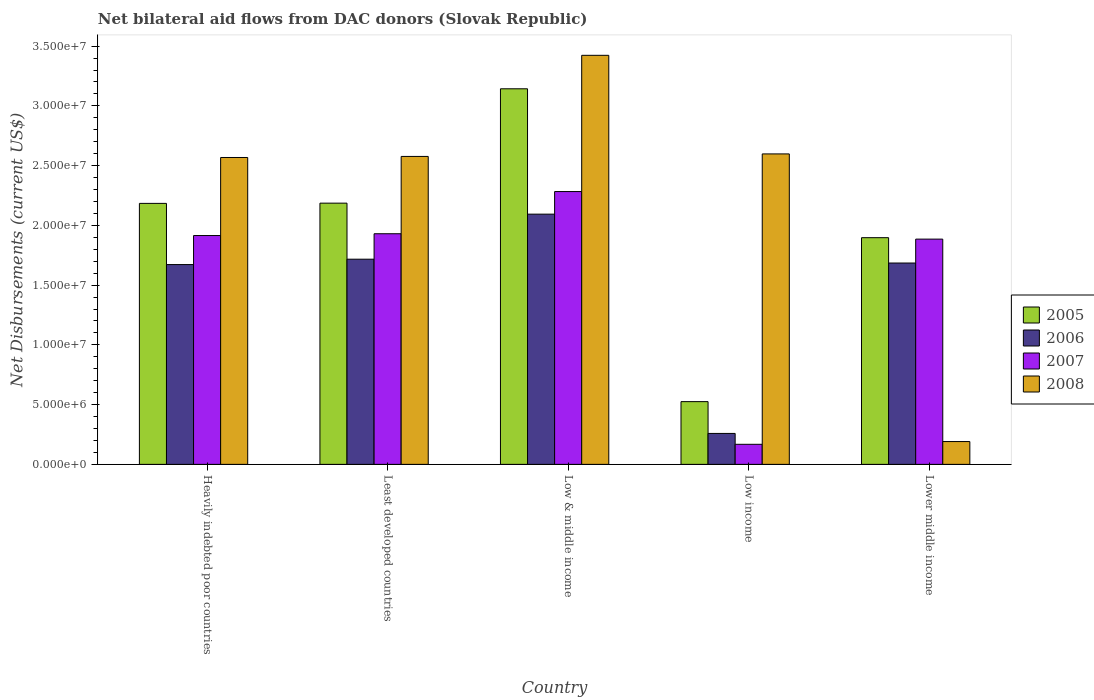How many different coloured bars are there?
Your answer should be compact. 4. Are the number of bars on each tick of the X-axis equal?
Offer a very short reply. Yes. What is the label of the 1st group of bars from the left?
Ensure brevity in your answer.  Heavily indebted poor countries. What is the net bilateral aid flows in 2005 in Low & middle income?
Your response must be concise. 3.14e+07. Across all countries, what is the maximum net bilateral aid flows in 2005?
Keep it short and to the point. 3.14e+07. Across all countries, what is the minimum net bilateral aid flows in 2006?
Make the answer very short. 2.59e+06. What is the total net bilateral aid flows in 2006 in the graph?
Provide a succinct answer. 7.43e+07. What is the difference between the net bilateral aid flows in 2007 in Heavily indebted poor countries and that in Low income?
Provide a short and direct response. 1.75e+07. What is the difference between the net bilateral aid flows in 2006 in Low income and the net bilateral aid flows in 2005 in Low & middle income?
Provide a succinct answer. -2.88e+07. What is the average net bilateral aid flows in 2006 per country?
Offer a terse response. 1.49e+07. What is the difference between the net bilateral aid flows of/in 2008 and net bilateral aid flows of/in 2005 in Lower middle income?
Offer a very short reply. -1.71e+07. In how many countries, is the net bilateral aid flows in 2005 greater than 29000000 US$?
Your response must be concise. 1. What is the ratio of the net bilateral aid flows in 2005 in Heavily indebted poor countries to that in Low & middle income?
Your answer should be compact. 0.69. Is the net bilateral aid flows in 2005 in Heavily indebted poor countries less than that in Lower middle income?
Offer a very short reply. No. Is the difference between the net bilateral aid flows in 2008 in Heavily indebted poor countries and Least developed countries greater than the difference between the net bilateral aid flows in 2005 in Heavily indebted poor countries and Least developed countries?
Give a very brief answer. No. What is the difference between the highest and the second highest net bilateral aid flows in 2006?
Give a very brief answer. 3.77e+06. What is the difference between the highest and the lowest net bilateral aid flows in 2007?
Make the answer very short. 2.12e+07. In how many countries, is the net bilateral aid flows in 2007 greater than the average net bilateral aid flows in 2007 taken over all countries?
Offer a very short reply. 4. Is it the case that in every country, the sum of the net bilateral aid flows in 2007 and net bilateral aid flows in 2006 is greater than the sum of net bilateral aid flows in 2008 and net bilateral aid flows in 2005?
Provide a succinct answer. No. How many bars are there?
Provide a succinct answer. 20. Are all the bars in the graph horizontal?
Make the answer very short. No. How many countries are there in the graph?
Ensure brevity in your answer.  5. What is the difference between two consecutive major ticks on the Y-axis?
Your answer should be very brief. 5.00e+06. Does the graph contain any zero values?
Give a very brief answer. No. Does the graph contain grids?
Provide a short and direct response. No. How many legend labels are there?
Ensure brevity in your answer.  4. How are the legend labels stacked?
Your response must be concise. Vertical. What is the title of the graph?
Your answer should be very brief. Net bilateral aid flows from DAC donors (Slovak Republic). Does "1979" appear as one of the legend labels in the graph?
Your answer should be very brief. No. What is the label or title of the Y-axis?
Offer a terse response. Net Disbursements (current US$). What is the Net Disbursements (current US$) in 2005 in Heavily indebted poor countries?
Give a very brief answer. 2.18e+07. What is the Net Disbursements (current US$) in 2006 in Heavily indebted poor countries?
Make the answer very short. 1.67e+07. What is the Net Disbursements (current US$) of 2007 in Heavily indebted poor countries?
Give a very brief answer. 1.92e+07. What is the Net Disbursements (current US$) of 2008 in Heavily indebted poor countries?
Make the answer very short. 2.57e+07. What is the Net Disbursements (current US$) in 2005 in Least developed countries?
Your response must be concise. 2.19e+07. What is the Net Disbursements (current US$) in 2006 in Least developed countries?
Your answer should be very brief. 1.72e+07. What is the Net Disbursements (current US$) in 2007 in Least developed countries?
Your answer should be very brief. 1.93e+07. What is the Net Disbursements (current US$) in 2008 in Least developed countries?
Ensure brevity in your answer.  2.58e+07. What is the Net Disbursements (current US$) of 2005 in Low & middle income?
Make the answer very short. 3.14e+07. What is the Net Disbursements (current US$) of 2006 in Low & middle income?
Your answer should be very brief. 2.09e+07. What is the Net Disbursements (current US$) in 2007 in Low & middle income?
Offer a very short reply. 2.28e+07. What is the Net Disbursements (current US$) in 2008 in Low & middle income?
Provide a short and direct response. 3.42e+07. What is the Net Disbursements (current US$) in 2005 in Low income?
Make the answer very short. 5.25e+06. What is the Net Disbursements (current US$) in 2006 in Low income?
Provide a succinct answer. 2.59e+06. What is the Net Disbursements (current US$) of 2007 in Low income?
Offer a terse response. 1.68e+06. What is the Net Disbursements (current US$) in 2008 in Low income?
Offer a terse response. 2.60e+07. What is the Net Disbursements (current US$) of 2005 in Lower middle income?
Ensure brevity in your answer.  1.90e+07. What is the Net Disbursements (current US$) in 2006 in Lower middle income?
Ensure brevity in your answer.  1.68e+07. What is the Net Disbursements (current US$) of 2007 in Lower middle income?
Your answer should be very brief. 1.88e+07. What is the Net Disbursements (current US$) in 2008 in Lower middle income?
Ensure brevity in your answer.  1.91e+06. Across all countries, what is the maximum Net Disbursements (current US$) of 2005?
Your answer should be very brief. 3.14e+07. Across all countries, what is the maximum Net Disbursements (current US$) of 2006?
Provide a short and direct response. 2.09e+07. Across all countries, what is the maximum Net Disbursements (current US$) in 2007?
Offer a very short reply. 2.28e+07. Across all countries, what is the maximum Net Disbursements (current US$) of 2008?
Your answer should be compact. 3.42e+07. Across all countries, what is the minimum Net Disbursements (current US$) of 2005?
Provide a short and direct response. 5.25e+06. Across all countries, what is the minimum Net Disbursements (current US$) of 2006?
Make the answer very short. 2.59e+06. Across all countries, what is the minimum Net Disbursements (current US$) in 2007?
Offer a very short reply. 1.68e+06. Across all countries, what is the minimum Net Disbursements (current US$) in 2008?
Make the answer very short. 1.91e+06. What is the total Net Disbursements (current US$) of 2005 in the graph?
Your answer should be compact. 9.94e+07. What is the total Net Disbursements (current US$) of 2006 in the graph?
Offer a terse response. 7.43e+07. What is the total Net Disbursements (current US$) of 2007 in the graph?
Make the answer very short. 8.18e+07. What is the total Net Disbursements (current US$) of 2008 in the graph?
Give a very brief answer. 1.14e+08. What is the difference between the Net Disbursements (current US$) in 2005 in Heavily indebted poor countries and that in Least developed countries?
Offer a very short reply. -2.00e+04. What is the difference between the Net Disbursements (current US$) of 2006 in Heavily indebted poor countries and that in Least developed countries?
Your response must be concise. -4.50e+05. What is the difference between the Net Disbursements (current US$) in 2007 in Heavily indebted poor countries and that in Least developed countries?
Offer a very short reply. -1.50e+05. What is the difference between the Net Disbursements (current US$) in 2005 in Heavily indebted poor countries and that in Low & middle income?
Your response must be concise. -9.59e+06. What is the difference between the Net Disbursements (current US$) in 2006 in Heavily indebted poor countries and that in Low & middle income?
Your answer should be compact. -4.22e+06. What is the difference between the Net Disbursements (current US$) in 2007 in Heavily indebted poor countries and that in Low & middle income?
Provide a succinct answer. -3.68e+06. What is the difference between the Net Disbursements (current US$) of 2008 in Heavily indebted poor countries and that in Low & middle income?
Make the answer very short. -8.55e+06. What is the difference between the Net Disbursements (current US$) in 2005 in Heavily indebted poor countries and that in Low income?
Offer a very short reply. 1.66e+07. What is the difference between the Net Disbursements (current US$) of 2006 in Heavily indebted poor countries and that in Low income?
Ensure brevity in your answer.  1.41e+07. What is the difference between the Net Disbursements (current US$) in 2007 in Heavily indebted poor countries and that in Low income?
Give a very brief answer. 1.75e+07. What is the difference between the Net Disbursements (current US$) in 2008 in Heavily indebted poor countries and that in Low income?
Give a very brief answer. -3.00e+05. What is the difference between the Net Disbursements (current US$) of 2005 in Heavily indebted poor countries and that in Lower middle income?
Offer a terse response. 2.87e+06. What is the difference between the Net Disbursements (current US$) in 2006 in Heavily indebted poor countries and that in Lower middle income?
Offer a very short reply. -1.30e+05. What is the difference between the Net Disbursements (current US$) of 2008 in Heavily indebted poor countries and that in Lower middle income?
Your answer should be compact. 2.38e+07. What is the difference between the Net Disbursements (current US$) of 2005 in Least developed countries and that in Low & middle income?
Keep it short and to the point. -9.57e+06. What is the difference between the Net Disbursements (current US$) in 2006 in Least developed countries and that in Low & middle income?
Make the answer very short. -3.77e+06. What is the difference between the Net Disbursements (current US$) of 2007 in Least developed countries and that in Low & middle income?
Your answer should be very brief. -3.53e+06. What is the difference between the Net Disbursements (current US$) in 2008 in Least developed countries and that in Low & middle income?
Give a very brief answer. -8.46e+06. What is the difference between the Net Disbursements (current US$) in 2005 in Least developed countries and that in Low income?
Ensure brevity in your answer.  1.66e+07. What is the difference between the Net Disbursements (current US$) in 2006 in Least developed countries and that in Low income?
Provide a succinct answer. 1.46e+07. What is the difference between the Net Disbursements (current US$) of 2007 in Least developed countries and that in Low income?
Offer a terse response. 1.76e+07. What is the difference between the Net Disbursements (current US$) of 2008 in Least developed countries and that in Low income?
Make the answer very short. -2.10e+05. What is the difference between the Net Disbursements (current US$) of 2005 in Least developed countries and that in Lower middle income?
Provide a succinct answer. 2.89e+06. What is the difference between the Net Disbursements (current US$) in 2007 in Least developed countries and that in Lower middle income?
Provide a succinct answer. 4.50e+05. What is the difference between the Net Disbursements (current US$) of 2008 in Least developed countries and that in Lower middle income?
Your answer should be compact. 2.39e+07. What is the difference between the Net Disbursements (current US$) in 2005 in Low & middle income and that in Low income?
Keep it short and to the point. 2.62e+07. What is the difference between the Net Disbursements (current US$) of 2006 in Low & middle income and that in Low income?
Provide a succinct answer. 1.84e+07. What is the difference between the Net Disbursements (current US$) in 2007 in Low & middle income and that in Low income?
Your answer should be very brief. 2.12e+07. What is the difference between the Net Disbursements (current US$) in 2008 in Low & middle income and that in Low income?
Offer a terse response. 8.25e+06. What is the difference between the Net Disbursements (current US$) of 2005 in Low & middle income and that in Lower middle income?
Offer a very short reply. 1.25e+07. What is the difference between the Net Disbursements (current US$) of 2006 in Low & middle income and that in Lower middle income?
Keep it short and to the point. 4.09e+06. What is the difference between the Net Disbursements (current US$) of 2007 in Low & middle income and that in Lower middle income?
Provide a short and direct response. 3.98e+06. What is the difference between the Net Disbursements (current US$) of 2008 in Low & middle income and that in Lower middle income?
Your answer should be compact. 3.23e+07. What is the difference between the Net Disbursements (current US$) of 2005 in Low income and that in Lower middle income?
Offer a terse response. -1.37e+07. What is the difference between the Net Disbursements (current US$) in 2006 in Low income and that in Lower middle income?
Offer a very short reply. -1.43e+07. What is the difference between the Net Disbursements (current US$) in 2007 in Low income and that in Lower middle income?
Make the answer very short. -1.72e+07. What is the difference between the Net Disbursements (current US$) of 2008 in Low income and that in Lower middle income?
Provide a succinct answer. 2.41e+07. What is the difference between the Net Disbursements (current US$) in 2005 in Heavily indebted poor countries and the Net Disbursements (current US$) in 2006 in Least developed countries?
Your response must be concise. 4.67e+06. What is the difference between the Net Disbursements (current US$) of 2005 in Heavily indebted poor countries and the Net Disbursements (current US$) of 2007 in Least developed countries?
Keep it short and to the point. 2.54e+06. What is the difference between the Net Disbursements (current US$) in 2005 in Heavily indebted poor countries and the Net Disbursements (current US$) in 2008 in Least developed countries?
Make the answer very short. -3.93e+06. What is the difference between the Net Disbursements (current US$) in 2006 in Heavily indebted poor countries and the Net Disbursements (current US$) in 2007 in Least developed countries?
Keep it short and to the point. -2.58e+06. What is the difference between the Net Disbursements (current US$) in 2006 in Heavily indebted poor countries and the Net Disbursements (current US$) in 2008 in Least developed countries?
Provide a short and direct response. -9.05e+06. What is the difference between the Net Disbursements (current US$) in 2007 in Heavily indebted poor countries and the Net Disbursements (current US$) in 2008 in Least developed countries?
Offer a terse response. -6.62e+06. What is the difference between the Net Disbursements (current US$) of 2005 in Heavily indebted poor countries and the Net Disbursements (current US$) of 2007 in Low & middle income?
Your answer should be very brief. -9.90e+05. What is the difference between the Net Disbursements (current US$) in 2005 in Heavily indebted poor countries and the Net Disbursements (current US$) in 2008 in Low & middle income?
Keep it short and to the point. -1.24e+07. What is the difference between the Net Disbursements (current US$) in 2006 in Heavily indebted poor countries and the Net Disbursements (current US$) in 2007 in Low & middle income?
Ensure brevity in your answer.  -6.11e+06. What is the difference between the Net Disbursements (current US$) of 2006 in Heavily indebted poor countries and the Net Disbursements (current US$) of 2008 in Low & middle income?
Provide a succinct answer. -1.75e+07. What is the difference between the Net Disbursements (current US$) of 2007 in Heavily indebted poor countries and the Net Disbursements (current US$) of 2008 in Low & middle income?
Offer a terse response. -1.51e+07. What is the difference between the Net Disbursements (current US$) in 2005 in Heavily indebted poor countries and the Net Disbursements (current US$) in 2006 in Low income?
Provide a short and direct response. 1.92e+07. What is the difference between the Net Disbursements (current US$) of 2005 in Heavily indebted poor countries and the Net Disbursements (current US$) of 2007 in Low income?
Your answer should be very brief. 2.02e+07. What is the difference between the Net Disbursements (current US$) of 2005 in Heavily indebted poor countries and the Net Disbursements (current US$) of 2008 in Low income?
Give a very brief answer. -4.14e+06. What is the difference between the Net Disbursements (current US$) of 2006 in Heavily indebted poor countries and the Net Disbursements (current US$) of 2007 in Low income?
Your answer should be very brief. 1.50e+07. What is the difference between the Net Disbursements (current US$) in 2006 in Heavily indebted poor countries and the Net Disbursements (current US$) in 2008 in Low income?
Ensure brevity in your answer.  -9.26e+06. What is the difference between the Net Disbursements (current US$) of 2007 in Heavily indebted poor countries and the Net Disbursements (current US$) of 2008 in Low income?
Provide a short and direct response. -6.83e+06. What is the difference between the Net Disbursements (current US$) of 2005 in Heavily indebted poor countries and the Net Disbursements (current US$) of 2006 in Lower middle income?
Provide a short and direct response. 4.99e+06. What is the difference between the Net Disbursements (current US$) of 2005 in Heavily indebted poor countries and the Net Disbursements (current US$) of 2007 in Lower middle income?
Your answer should be very brief. 2.99e+06. What is the difference between the Net Disbursements (current US$) of 2005 in Heavily indebted poor countries and the Net Disbursements (current US$) of 2008 in Lower middle income?
Your response must be concise. 1.99e+07. What is the difference between the Net Disbursements (current US$) of 2006 in Heavily indebted poor countries and the Net Disbursements (current US$) of 2007 in Lower middle income?
Your answer should be very brief. -2.13e+06. What is the difference between the Net Disbursements (current US$) in 2006 in Heavily indebted poor countries and the Net Disbursements (current US$) in 2008 in Lower middle income?
Provide a succinct answer. 1.48e+07. What is the difference between the Net Disbursements (current US$) of 2007 in Heavily indebted poor countries and the Net Disbursements (current US$) of 2008 in Lower middle income?
Offer a terse response. 1.72e+07. What is the difference between the Net Disbursements (current US$) in 2005 in Least developed countries and the Net Disbursements (current US$) in 2006 in Low & middle income?
Provide a short and direct response. 9.20e+05. What is the difference between the Net Disbursements (current US$) of 2005 in Least developed countries and the Net Disbursements (current US$) of 2007 in Low & middle income?
Give a very brief answer. -9.70e+05. What is the difference between the Net Disbursements (current US$) in 2005 in Least developed countries and the Net Disbursements (current US$) in 2008 in Low & middle income?
Make the answer very short. -1.24e+07. What is the difference between the Net Disbursements (current US$) of 2006 in Least developed countries and the Net Disbursements (current US$) of 2007 in Low & middle income?
Your response must be concise. -5.66e+06. What is the difference between the Net Disbursements (current US$) of 2006 in Least developed countries and the Net Disbursements (current US$) of 2008 in Low & middle income?
Ensure brevity in your answer.  -1.71e+07. What is the difference between the Net Disbursements (current US$) in 2007 in Least developed countries and the Net Disbursements (current US$) in 2008 in Low & middle income?
Ensure brevity in your answer.  -1.49e+07. What is the difference between the Net Disbursements (current US$) of 2005 in Least developed countries and the Net Disbursements (current US$) of 2006 in Low income?
Offer a terse response. 1.93e+07. What is the difference between the Net Disbursements (current US$) in 2005 in Least developed countries and the Net Disbursements (current US$) in 2007 in Low income?
Your answer should be compact. 2.02e+07. What is the difference between the Net Disbursements (current US$) of 2005 in Least developed countries and the Net Disbursements (current US$) of 2008 in Low income?
Give a very brief answer. -4.12e+06. What is the difference between the Net Disbursements (current US$) in 2006 in Least developed countries and the Net Disbursements (current US$) in 2007 in Low income?
Keep it short and to the point. 1.55e+07. What is the difference between the Net Disbursements (current US$) of 2006 in Least developed countries and the Net Disbursements (current US$) of 2008 in Low income?
Make the answer very short. -8.81e+06. What is the difference between the Net Disbursements (current US$) of 2007 in Least developed countries and the Net Disbursements (current US$) of 2008 in Low income?
Provide a short and direct response. -6.68e+06. What is the difference between the Net Disbursements (current US$) of 2005 in Least developed countries and the Net Disbursements (current US$) of 2006 in Lower middle income?
Make the answer very short. 5.01e+06. What is the difference between the Net Disbursements (current US$) in 2005 in Least developed countries and the Net Disbursements (current US$) in 2007 in Lower middle income?
Keep it short and to the point. 3.01e+06. What is the difference between the Net Disbursements (current US$) in 2005 in Least developed countries and the Net Disbursements (current US$) in 2008 in Lower middle income?
Your answer should be very brief. 2.00e+07. What is the difference between the Net Disbursements (current US$) in 2006 in Least developed countries and the Net Disbursements (current US$) in 2007 in Lower middle income?
Your answer should be compact. -1.68e+06. What is the difference between the Net Disbursements (current US$) of 2006 in Least developed countries and the Net Disbursements (current US$) of 2008 in Lower middle income?
Ensure brevity in your answer.  1.53e+07. What is the difference between the Net Disbursements (current US$) in 2007 in Least developed countries and the Net Disbursements (current US$) in 2008 in Lower middle income?
Provide a succinct answer. 1.74e+07. What is the difference between the Net Disbursements (current US$) of 2005 in Low & middle income and the Net Disbursements (current US$) of 2006 in Low income?
Provide a short and direct response. 2.88e+07. What is the difference between the Net Disbursements (current US$) in 2005 in Low & middle income and the Net Disbursements (current US$) in 2007 in Low income?
Provide a succinct answer. 2.98e+07. What is the difference between the Net Disbursements (current US$) in 2005 in Low & middle income and the Net Disbursements (current US$) in 2008 in Low income?
Give a very brief answer. 5.45e+06. What is the difference between the Net Disbursements (current US$) in 2006 in Low & middle income and the Net Disbursements (current US$) in 2007 in Low income?
Give a very brief answer. 1.93e+07. What is the difference between the Net Disbursements (current US$) in 2006 in Low & middle income and the Net Disbursements (current US$) in 2008 in Low income?
Keep it short and to the point. -5.04e+06. What is the difference between the Net Disbursements (current US$) of 2007 in Low & middle income and the Net Disbursements (current US$) of 2008 in Low income?
Your response must be concise. -3.15e+06. What is the difference between the Net Disbursements (current US$) in 2005 in Low & middle income and the Net Disbursements (current US$) in 2006 in Lower middle income?
Offer a very short reply. 1.46e+07. What is the difference between the Net Disbursements (current US$) in 2005 in Low & middle income and the Net Disbursements (current US$) in 2007 in Lower middle income?
Your answer should be compact. 1.26e+07. What is the difference between the Net Disbursements (current US$) of 2005 in Low & middle income and the Net Disbursements (current US$) of 2008 in Lower middle income?
Provide a succinct answer. 2.95e+07. What is the difference between the Net Disbursements (current US$) of 2006 in Low & middle income and the Net Disbursements (current US$) of 2007 in Lower middle income?
Give a very brief answer. 2.09e+06. What is the difference between the Net Disbursements (current US$) in 2006 in Low & middle income and the Net Disbursements (current US$) in 2008 in Lower middle income?
Make the answer very short. 1.90e+07. What is the difference between the Net Disbursements (current US$) in 2007 in Low & middle income and the Net Disbursements (current US$) in 2008 in Lower middle income?
Your answer should be very brief. 2.09e+07. What is the difference between the Net Disbursements (current US$) in 2005 in Low income and the Net Disbursements (current US$) in 2006 in Lower middle income?
Keep it short and to the point. -1.16e+07. What is the difference between the Net Disbursements (current US$) of 2005 in Low income and the Net Disbursements (current US$) of 2007 in Lower middle income?
Your answer should be compact. -1.36e+07. What is the difference between the Net Disbursements (current US$) in 2005 in Low income and the Net Disbursements (current US$) in 2008 in Lower middle income?
Your answer should be very brief. 3.34e+06. What is the difference between the Net Disbursements (current US$) of 2006 in Low income and the Net Disbursements (current US$) of 2007 in Lower middle income?
Provide a short and direct response. -1.63e+07. What is the difference between the Net Disbursements (current US$) of 2006 in Low income and the Net Disbursements (current US$) of 2008 in Lower middle income?
Your response must be concise. 6.80e+05. What is the difference between the Net Disbursements (current US$) of 2007 in Low income and the Net Disbursements (current US$) of 2008 in Lower middle income?
Your answer should be compact. -2.30e+05. What is the average Net Disbursements (current US$) in 2005 per country?
Ensure brevity in your answer.  1.99e+07. What is the average Net Disbursements (current US$) in 2006 per country?
Keep it short and to the point. 1.49e+07. What is the average Net Disbursements (current US$) of 2007 per country?
Make the answer very short. 1.64e+07. What is the average Net Disbursements (current US$) of 2008 per country?
Your response must be concise. 2.27e+07. What is the difference between the Net Disbursements (current US$) of 2005 and Net Disbursements (current US$) of 2006 in Heavily indebted poor countries?
Your answer should be very brief. 5.12e+06. What is the difference between the Net Disbursements (current US$) of 2005 and Net Disbursements (current US$) of 2007 in Heavily indebted poor countries?
Provide a succinct answer. 2.69e+06. What is the difference between the Net Disbursements (current US$) in 2005 and Net Disbursements (current US$) in 2008 in Heavily indebted poor countries?
Offer a very short reply. -3.84e+06. What is the difference between the Net Disbursements (current US$) of 2006 and Net Disbursements (current US$) of 2007 in Heavily indebted poor countries?
Your answer should be compact. -2.43e+06. What is the difference between the Net Disbursements (current US$) in 2006 and Net Disbursements (current US$) in 2008 in Heavily indebted poor countries?
Keep it short and to the point. -8.96e+06. What is the difference between the Net Disbursements (current US$) of 2007 and Net Disbursements (current US$) of 2008 in Heavily indebted poor countries?
Give a very brief answer. -6.53e+06. What is the difference between the Net Disbursements (current US$) in 2005 and Net Disbursements (current US$) in 2006 in Least developed countries?
Your response must be concise. 4.69e+06. What is the difference between the Net Disbursements (current US$) in 2005 and Net Disbursements (current US$) in 2007 in Least developed countries?
Your answer should be compact. 2.56e+06. What is the difference between the Net Disbursements (current US$) of 2005 and Net Disbursements (current US$) of 2008 in Least developed countries?
Your answer should be compact. -3.91e+06. What is the difference between the Net Disbursements (current US$) of 2006 and Net Disbursements (current US$) of 2007 in Least developed countries?
Provide a succinct answer. -2.13e+06. What is the difference between the Net Disbursements (current US$) of 2006 and Net Disbursements (current US$) of 2008 in Least developed countries?
Ensure brevity in your answer.  -8.60e+06. What is the difference between the Net Disbursements (current US$) of 2007 and Net Disbursements (current US$) of 2008 in Least developed countries?
Offer a terse response. -6.47e+06. What is the difference between the Net Disbursements (current US$) of 2005 and Net Disbursements (current US$) of 2006 in Low & middle income?
Make the answer very short. 1.05e+07. What is the difference between the Net Disbursements (current US$) in 2005 and Net Disbursements (current US$) in 2007 in Low & middle income?
Your response must be concise. 8.60e+06. What is the difference between the Net Disbursements (current US$) in 2005 and Net Disbursements (current US$) in 2008 in Low & middle income?
Provide a succinct answer. -2.80e+06. What is the difference between the Net Disbursements (current US$) of 2006 and Net Disbursements (current US$) of 2007 in Low & middle income?
Offer a terse response. -1.89e+06. What is the difference between the Net Disbursements (current US$) of 2006 and Net Disbursements (current US$) of 2008 in Low & middle income?
Offer a terse response. -1.33e+07. What is the difference between the Net Disbursements (current US$) in 2007 and Net Disbursements (current US$) in 2008 in Low & middle income?
Ensure brevity in your answer.  -1.14e+07. What is the difference between the Net Disbursements (current US$) of 2005 and Net Disbursements (current US$) of 2006 in Low income?
Make the answer very short. 2.66e+06. What is the difference between the Net Disbursements (current US$) in 2005 and Net Disbursements (current US$) in 2007 in Low income?
Your answer should be very brief. 3.57e+06. What is the difference between the Net Disbursements (current US$) in 2005 and Net Disbursements (current US$) in 2008 in Low income?
Offer a terse response. -2.07e+07. What is the difference between the Net Disbursements (current US$) of 2006 and Net Disbursements (current US$) of 2007 in Low income?
Provide a succinct answer. 9.10e+05. What is the difference between the Net Disbursements (current US$) in 2006 and Net Disbursements (current US$) in 2008 in Low income?
Offer a very short reply. -2.34e+07. What is the difference between the Net Disbursements (current US$) in 2007 and Net Disbursements (current US$) in 2008 in Low income?
Your answer should be very brief. -2.43e+07. What is the difference between the Net Disbursements (current US$) in 2005 and Net Disbursements (current US$) in 2006 in Lower middle income?
Keep it short and to the point. 2.12e+06. What is the difference between the Net Disbursements (current US$) in 2005 and Net Disbursements (current US$) in 2008 in Lower middle income?
Your response must be concise. 1.71e+07. What is the difference between the Net Disbursements (current US$) in 2006 and Net Disbursements (current US$) in 2008 in Lower middle income?
Your answer should be very brief. 1.49e+07. What is the difference between the Net Disbursements (current US$) of 2007 and Net Disbursements (current US$) of 2008 in Lower middle income?
Give a very brief answer. 1.69e+07. What is the ratio of the Net Disbursements (current US$) in 2006 in Heavily indebted poor countries to that in Least developed countries?
Give a very brief answer. 0.97. What is the ratio of the Net Disbursements (current US$) of 2007 in Heavily indebted poor countries to that in Least developed countries?
Provide a short and direct response. 0.99. What is the ratio of the Net Disbursements (current US$) of 2008 in Heavily indebted poor countries to that in Least developed countries?
Your response must be concise. 1. What is the ratio of the Net Disbursements (current US$) in 2005 in Heavily indebted poor countries to that in Low & middle income?
Provide a succinct answer. 0.69. What is the ratio of the Net Disbursements (current US$) of 2006 in Heavily indebted poor countries to that in Low & middle income?
Your answer should be compact. 0.8. What is the ratio of the Net Disbursements (current US$) in 2007 in Heavily indebted poor countries to that in Low & middle income?
Your response must be concise. 0.84. What is the ratio of the Net Disbursements (current US$) of 2008 in Heavily indebted poor countries to that in Low & middle income?
Offer a very short reply. 0.75. What is the ratio of the Net Disbursements (current US$) in 2005 in Heavily indebted poor countries to that in Low income?
Your answer should be very brief. 4.16. What is the ratio of the Net Disbursements (current US$) in 2006 in Heavily indebted poor countries to that in Low income?
Ensure brevity in your answer.  6.46. What is the ratio of the Net Disbursements (current US$) of 2007 in Heavily indebted poor countries to that in Low income?
Provide a short and direct response. 11.4. What is the ratio of the Net Disbursements (current US$) of 2005 in Heavily indebted poor countries to that in Lower middle income?
Offer a terse response. 1.15. What is the ratio of the Net Disbursements (current US$) in 2006 in Heavily indebted poor countries to that in Lower middle income?
Make the answer very short. 0.99. What is the ratio of the Net Disbursements (current US$) in 2007 in Heavily indebted poor countries to that in Lower middle income?
Your response must be concise. 1.02. What is the ratio of the Net Disbursements (current US$) in 2008 in Heavily indebted poor countries to that in Lower middle income?
Ensure brevity in your answer.  13.45. What is the ratio of the Net Disbursements (current US$) in 2005 in Least developed countries to that in Low & middle income?
Your answer should be compact. 0.7. What is the ratio of the Net Disbursements (current US$) in 2006 in Least developed countries to that in Low & middle income?
Provide a succinct answer. 0.82. What is the ratio of the Net Disbursements (current US$) of 2007 in Least developed countries to that in Low & middle income?
Keep it short and to the point. 0.85. What is the ratio of the Net Disbursements (current US$) of 2008 in Least developed countries to that in Low & middle income?
Provide a succinct answer. 0.75. What is the ratio of the Net Disbursements (current US$) in 2005 in Least developed countries to that in Low income?
Provide a short and direct response. 4.16. What is the ratio of the Net Disbursements (current US$) in 2006 in Least developed countries to that in Low income?
Provide a short and direct response. 6.63. What is the ratio of the Net Disbursements (current US$) in 2007 in Least developed countries to that in Low income?
Your answer should be compact. 11.49. What is the ratio of the Net Disbursements (current US$) of 2008 in Least developed countries to that in Low income?
Provide a short and direct response. 0.99. What is the ratio of the Net Disbursements (current US$) of 2005 in Least developed countries to that in Lower middle income?
Offer a terse response. 1.15. What is the ratio of the Net Disbursements (current US$) of 2007 in Least developed countries to that in Lower middle income?
Offer a very short reply. 1.02. What is the ratio of the Net Disbursements (current US$) in 2008 in Least developed countries to that in Lower middle income?
Your answer should be very brief. 13.49. What is the ratio of the Net Disbursements (current US$) in 2005 in Low & middle income to that in Low income?
Give a very brief answer. 5.99. What is the ratio of the Net Disbursements (current US$) in 2006 in Low & middle income to that in Low income?
Your answer should be compact. 8.08. What is the ratio of the Net Disbursements (current US$) of 2007 in Low & middle income to that in Low income?
Keep it short and to the point. 13.59. What is the ratio of the Net Disbursements (current US$) in 2008 in Low & middle income to that in Low income?
Offer a terse response. 1.32. What is the ratio of the Net Disbursements (current US$) in 2005 in Low & middle income to that in Lower middle income?
Ensure brevity in your answer.  1.66. What is the ratio of the Net Disbursements (current US$) of 2006 in Low & middle income to that in Lower middle income?
Offer a very short reply. 1.24. What is the ratio of the Net Disbursements (current US$) in 2007 in Low & middle income to that in Lower middle income?
Keep it short and to the point. 1.21. What is the ratio of the Net Disbursements (current US$) of 2008 in Low & middle income to that in Lower middle income?
Provide a succinct answer. 17.92. What is the ratio of the Net Disbursements (current US$) in 2005 in Low income to that in Lower middle income?
Provide a short and direct response. 0.28. What is the ratio of the Net Disbursements (current US$) of 2006 in Low income to that in Lower middle income?
Provide a short and direct response. 0.15. What is the ratio of the Net Disbursements (current US$) of 2007 in Low income to that in Lower middle income?
Give a very brief answer. 0.09. What is the ratio of the Net Disbursements (current US$) in 2008 in Low income to that in Lower middle income?
Keep it short and to the point. 13.6. What is the difference between the highest and the second highest Net Disbursements (current US$) in 2005?
Your answer should be very brief. 9.57e+06. What is the difference between the highest and the second highest Net Disbursements (current US$) in 2006?
Ensure brevity in your answer.  3.77e+06. What is the difference between the highest and the second highest Net Disbursements (current US$) of 2007?
Your response must be concise. 3.53e+06. What is the difference between the highest and the second highest Net Disbursements (current US$) in 2008?
Provide a short and direct response. 8.25e+06. What is the difference between the highest and the lowest Net Disbursements (current US$) in 2005?
Provide a succinct answer. 2.62e+07. What is the difference between the highest and the lowest Net Disbursements (current US$) of 2006?
Your answer should be very brief. 1.84e+07. What is the difference between the highest and the lowest Net Disbursements (current US$) in 2007?
Keep it short and to the point. 2.12e+07. What is the difference between the highest and the lowest Net Disbursements (current US$) of 2008?
Offer a terse response. 3.23e+07. 